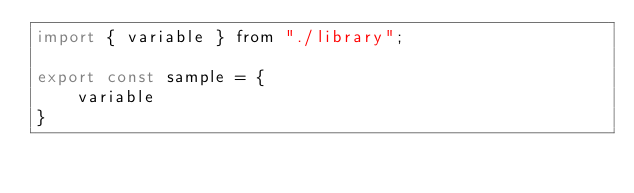Convert code to text. <code><loc_0><loc_0><loc_500><loc_500><_JavaScript_>import { variable } from "./library";

export const sample = {
    variable
}
</code> 